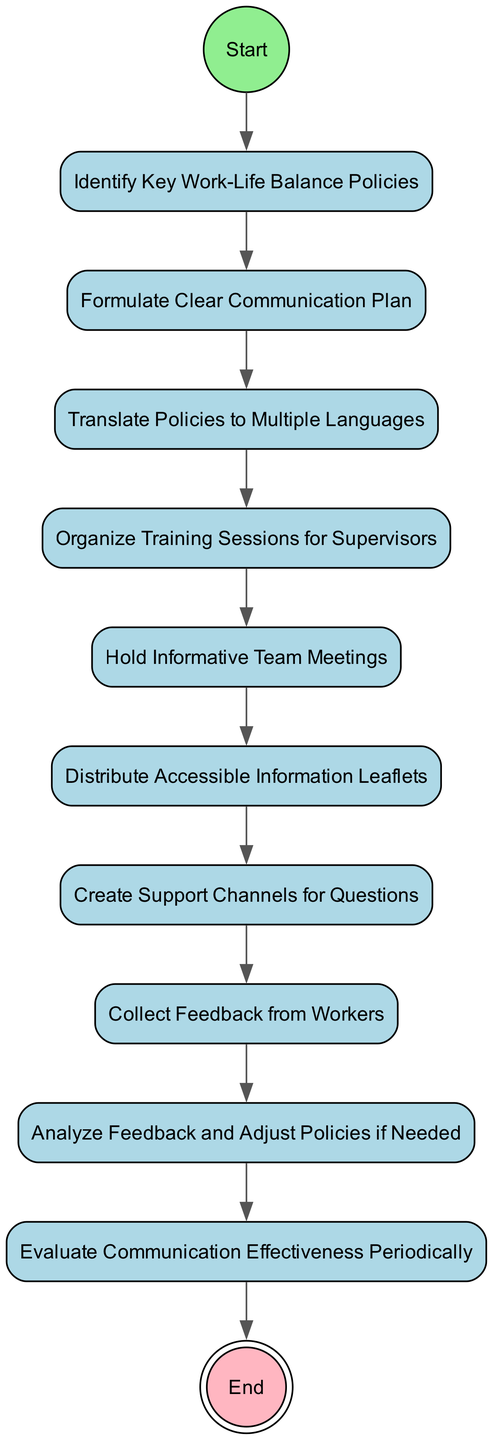What is the first step in the activity diagram? The diagram starts with the node labeled "Start," from which the first activity node is "Identify Key Work-Life Balance Policies."
Answer: Identify Key Work-Life Balance Policies How many activity nodes are present in the diagram? By counting the activity nodes in the diagram, there are a total of nine activity nodes listed, from "Identify Key Work-Life Balance Policies" to "Evaluate Communication Effectiveness Periodically."
Answer: Nine What comes immediately after "Formulate Clear Communication Plan"? Following the "Formulate Clear Communication Plan," the next activity node is "Translate Policies to Multiple Languages," as indicated by the directed transition in the diagram.
Answer: Translate Policies to Multiple Languages Which step involves gathering input from factory workers? The step where feedback is collected from factory workers is labeled "Collect Feedback from Workers," which follows the establishment of support channels for questions.
Answer: Collect Feedback from Workers What is the last activity before reaching the end of the diagram? The last activity that occurs before reaching the "End" node is "Evaluate Communication Effectiveness Periodically," as seen in the flow of the diagram.
Answer: Evaluate Communication Effectiveness Periodically How many transitions connect the nodes in this diagram? There are a total of ten transitions that connect the activity nodes within the diagram, moving sequentially from start to end.
Answer: Ten What step comes just before distributing leaflets? The step that comes just before distributing accessible information leaflets is "Hold Informative Team Meetings," indicating a progression in the communication plan.
Answer: Hold Informative Team Meetings Which activity focuses on training supervisors? The activity dedicated to training supervisors is labeled "Organize Training Sessions for Supervisors," highlighting the importance of equipping them for better communication.
Answer: Organize Training Sessions for Supervisors 